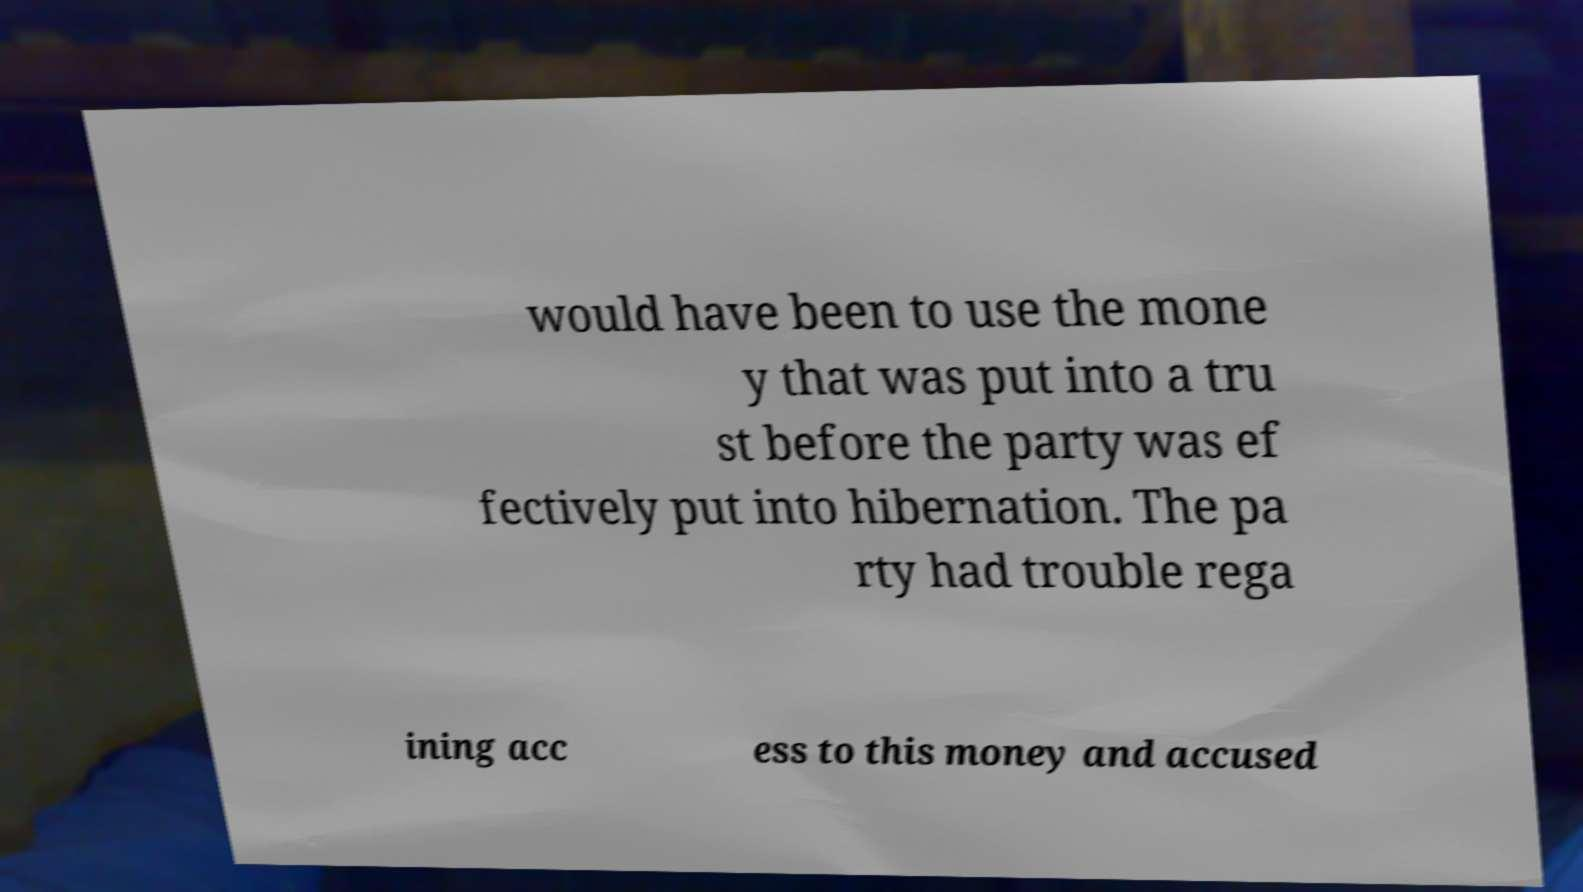There's text embedded in this image that I need extracted. Can you transcribe it verbatim? would have been to use the mone y that was put into a tru st before the party was ef fectively put into hibernation. The pa rty had trouble rega ining acc ess to this money and accused 